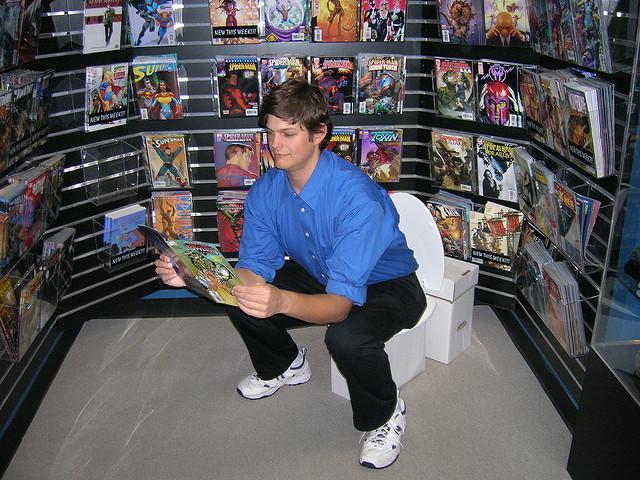What type of store is this?
From the following four choices, select the correct answer to address the question.
Options: Comic, grocery, beauty, store. Comic. 